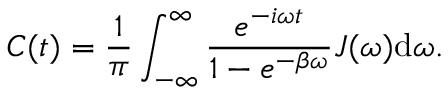Convert formula to latex. <formula><loc_0><loc_0><loc_500><loc_500>C ( t ) = \frac { 1 } { \pi } \int _ { - \infty } ^ { \infty } \frac { e ^ { - i \omega t } } { 1 - e ^ { - \beta \omega } } J ( \omega ) d \omega .</formula> 